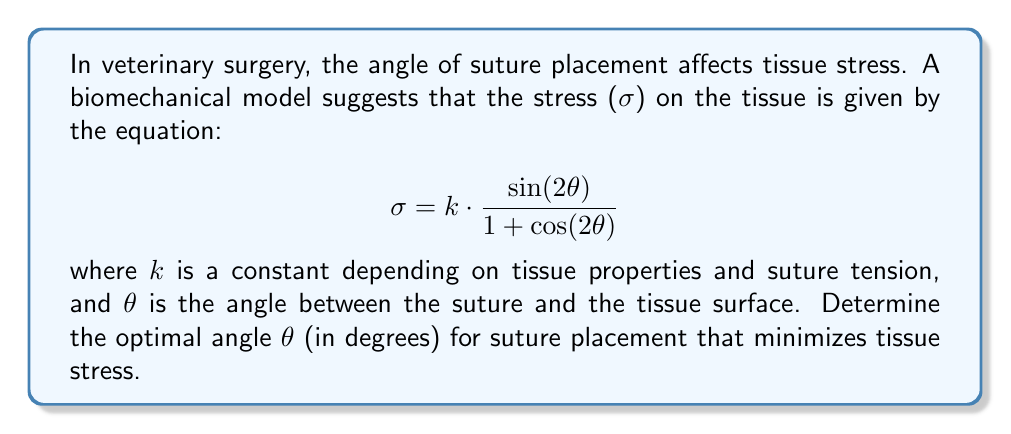Help me with this question. To find the optimal angle that minimizes tissue stress, we need to find the minimum of the given function. This can be done by following these steps:

1) First, we need to find the derivative of σ with respect to θ:

   $$\frac{dσ}{dθ} = k \cdot \frac{2\cos(2θ)(1 + \cos(2θ)) - \sin(2θ)(-2\sin(2θ))}{(1 + \cos(2θ))^2}$$

2) Simplify this expression:

   $$\frac{dσ}{dθ} = k \cdot \frac{2\cos(2θ) + 2\cos^2(2θ) + 2\sin^2(2θ)}{(1 + \cos(2θ))^2}$$

3) Use the identity $\sin^2(2θ) + \cos^2(2θ) = 1$ to further simplify:

   $$\frac{dσ}{dθ} = k \cdot \frac{2\cos(2θ) + 2}{(1 + \cos(2θ))^2}$$

4) To find the minimum, set this derivative to zero:

   $$k \cdot \frac{2\cos(2θ) + 2}{(1 + \cos(2θ))^2} = 0$$

5) Since k is a non-zero constant, we can solve:

   $$2\cos(2θ) + 2 = 0$$
   $$\cos(2θ) = -1$$

6) Solve for θ:

   $$2θ = \arccos(-1) = π$$
   $$θ = \frac{π}{2} = 90°$$

7) To confirm this is a minimum (not a maximum), we can check the second derivative is positive at this point (omitted for brevity).

Therefore, the optimal angle for suture placement to minimize tissue stress is 90°.
Answer: 90° 